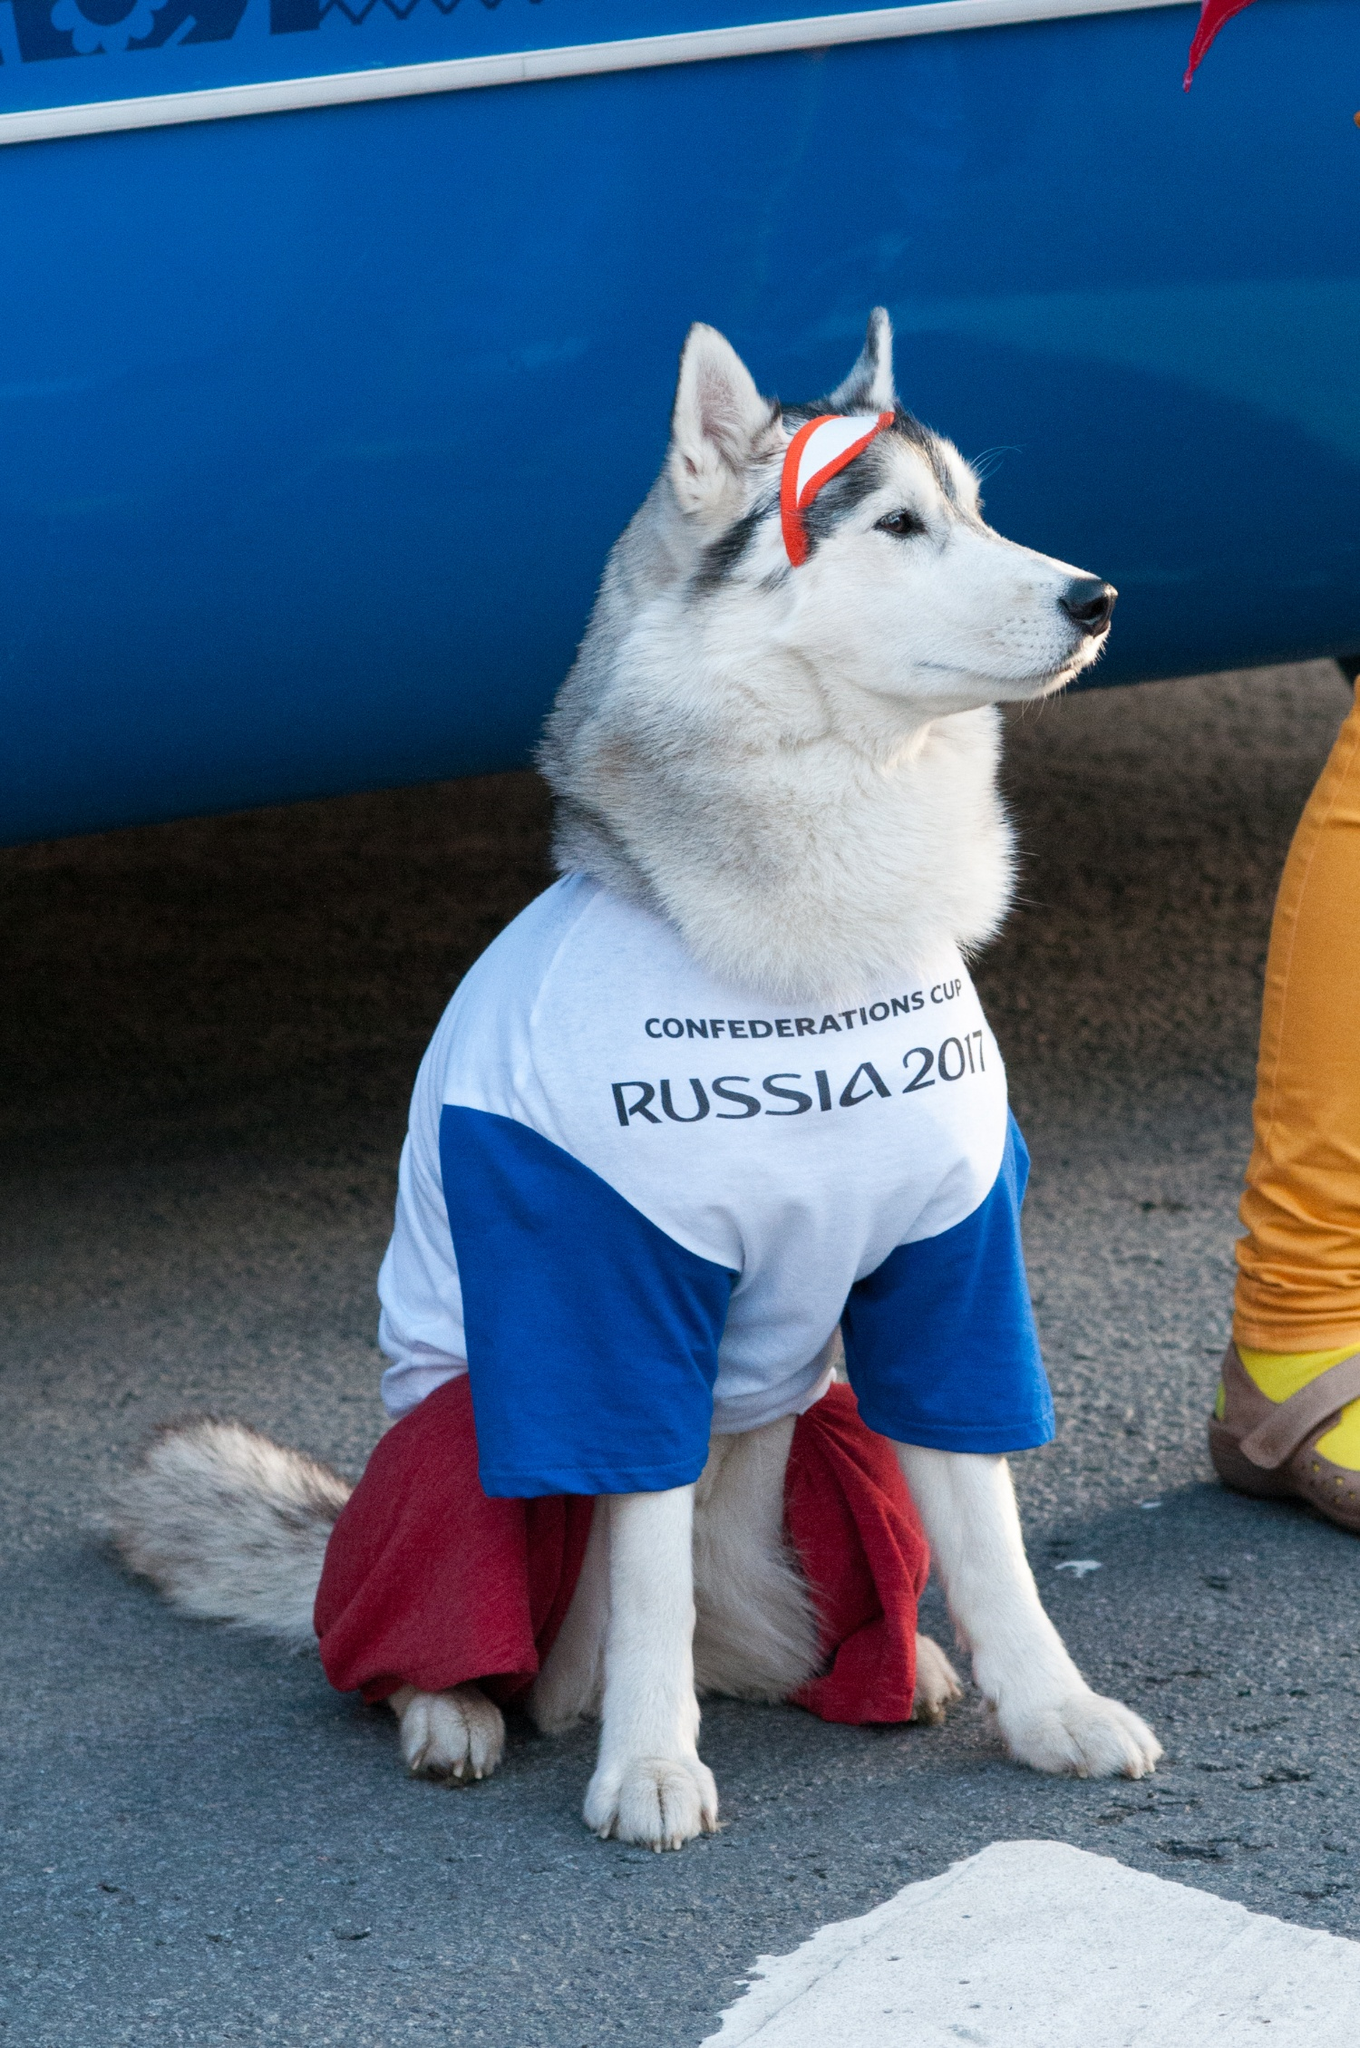Describe the following image. The image features a beautiful white and grey Siberian Husky sitting on the ground as the central focus. The Husky is adorned with festive clothing, including a white t-shirt with blue sleeves that reads "CONFEDERATIONS CUP RUSSIA 2017" in bold letters on the front. Additionally, the dog is dressed in red pants and has a red headband with white stripes, giving it a charming and celebratory appearance. The dog is situated in front of a vivid blue banner, which adds to the vibrant color scheme of the scene. On the right side of the image, part of a person’s leg, dressed in yellow pants and colorful shoes, can be seen. The overall setting suggests that the image was taken during a special event or celebration where the dog was likely a significant attraction, adorned with colors that stand out against its white fur and the background. 